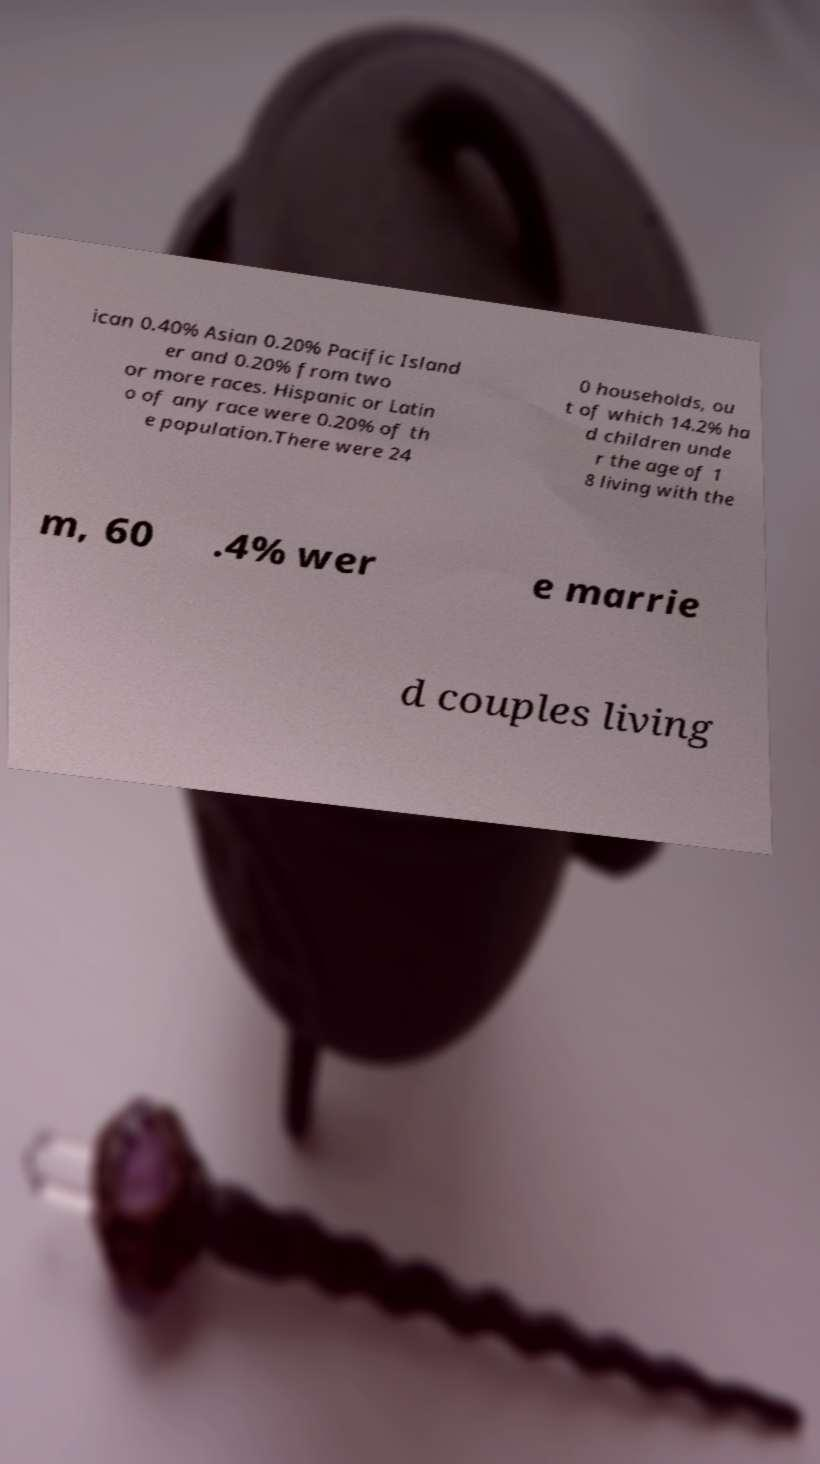I need the written content from this picture converted into text. Can you do that? ican 0.40% Asian 0.20% Pacific Island er and 0.20% from two or more races. Hispanic or Latin o of any race were 0.20% of th e population.There were 24 0 households, ou t of which 14.2% ha d children unde r the age of 1 8 living with the m, 60 .4% wer e marrie d couples living 